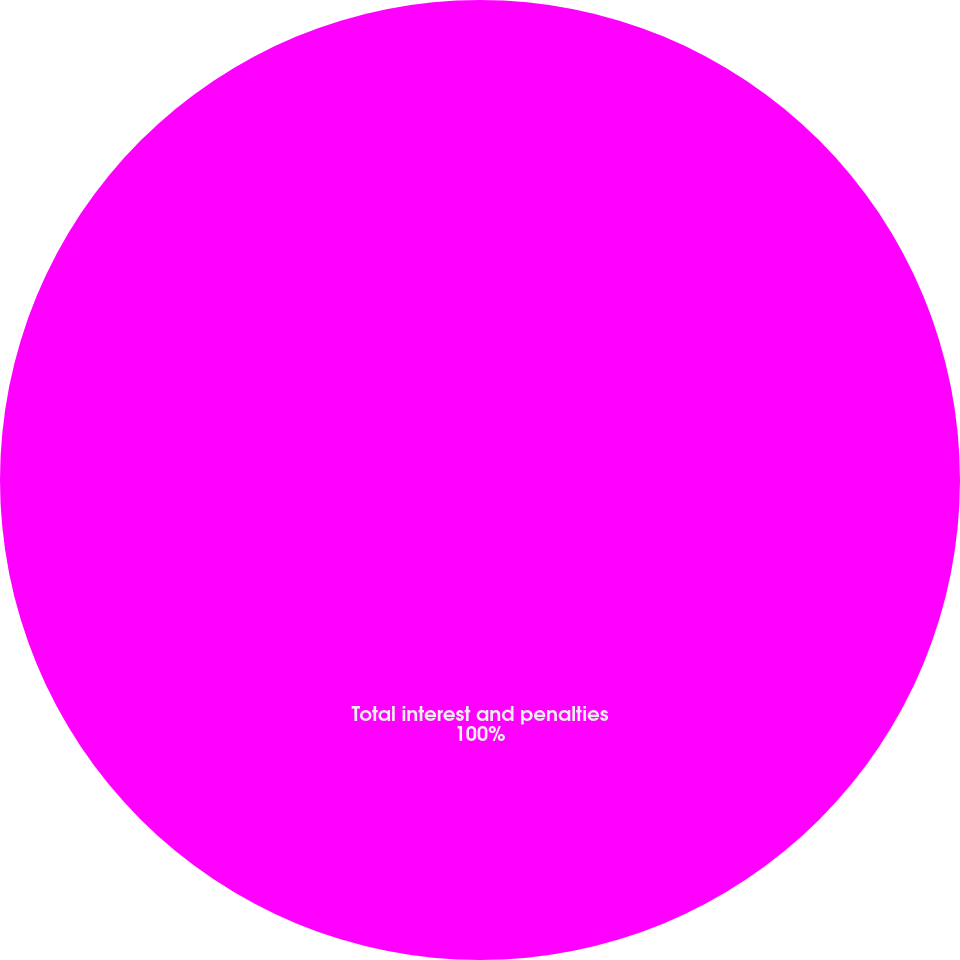<chart> <loc_0><loc_0><loc_500><loc_500><pie_chart><fcel>Total interest and penalties<nl><fcel>100.0%<nl></chart> 